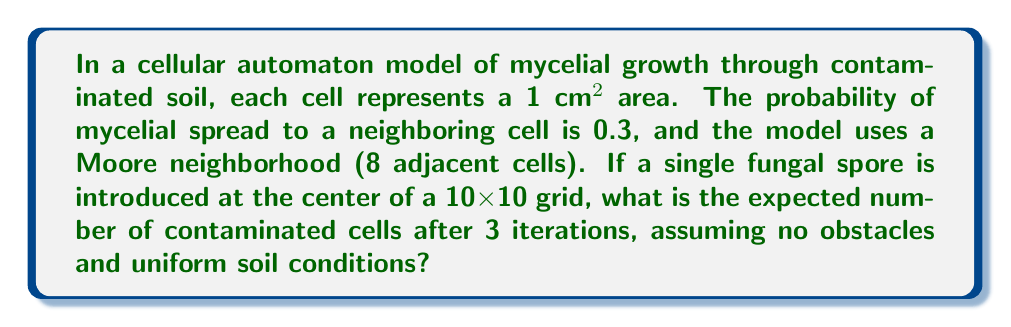What is the answer to this math problem? Let's approach this step-by-step:

1) In the first iteration (t=0), we start with 1 contaminated cell at the center.

2) For each subsequent iteration:
   - Each contaminated cell has 8 neighbors (Moore neighborhood)
   - The probability of spreading to each neighbor is 0.3

3) Let's calculate the expected number of newly contaminated cells for each iteration:

   Iteration 1 (t=1):
   - 1 contaminated cell from t=0
   - Expected new cells = $1 \times 8 \times 0.3 = 2.4$
   - Total expected at t=1: $1 + 2.4 = 3.4$

   Iteration 2 (t=2):
   - 3.4 contaminated cells from t=1
   - Expected new cells = $3.4 \times 8 \times 0.3 = 8.16$
   - Total expected at t=2: $3.4 + 8.16 = 11.56$

   Iteration 3 (t=3):
   - 11.56 contaminated cells from t=2
   - Expected new cells = $11.56 \times 8 \times 0.3 = 27.744$
   - Total expected at t=3: $11.56 + 27.744 = 39.304$

4) Therefore, after 3 iterations, the expected number of contaminated cells is 39.304.

5) Note: This model assumes that cells can be fractionally contaminated, which is a simplification. In a more complex model, we might use probabilistic rounding or other techniques to maintain integer cell counts.
Answer: 39.304 cells 